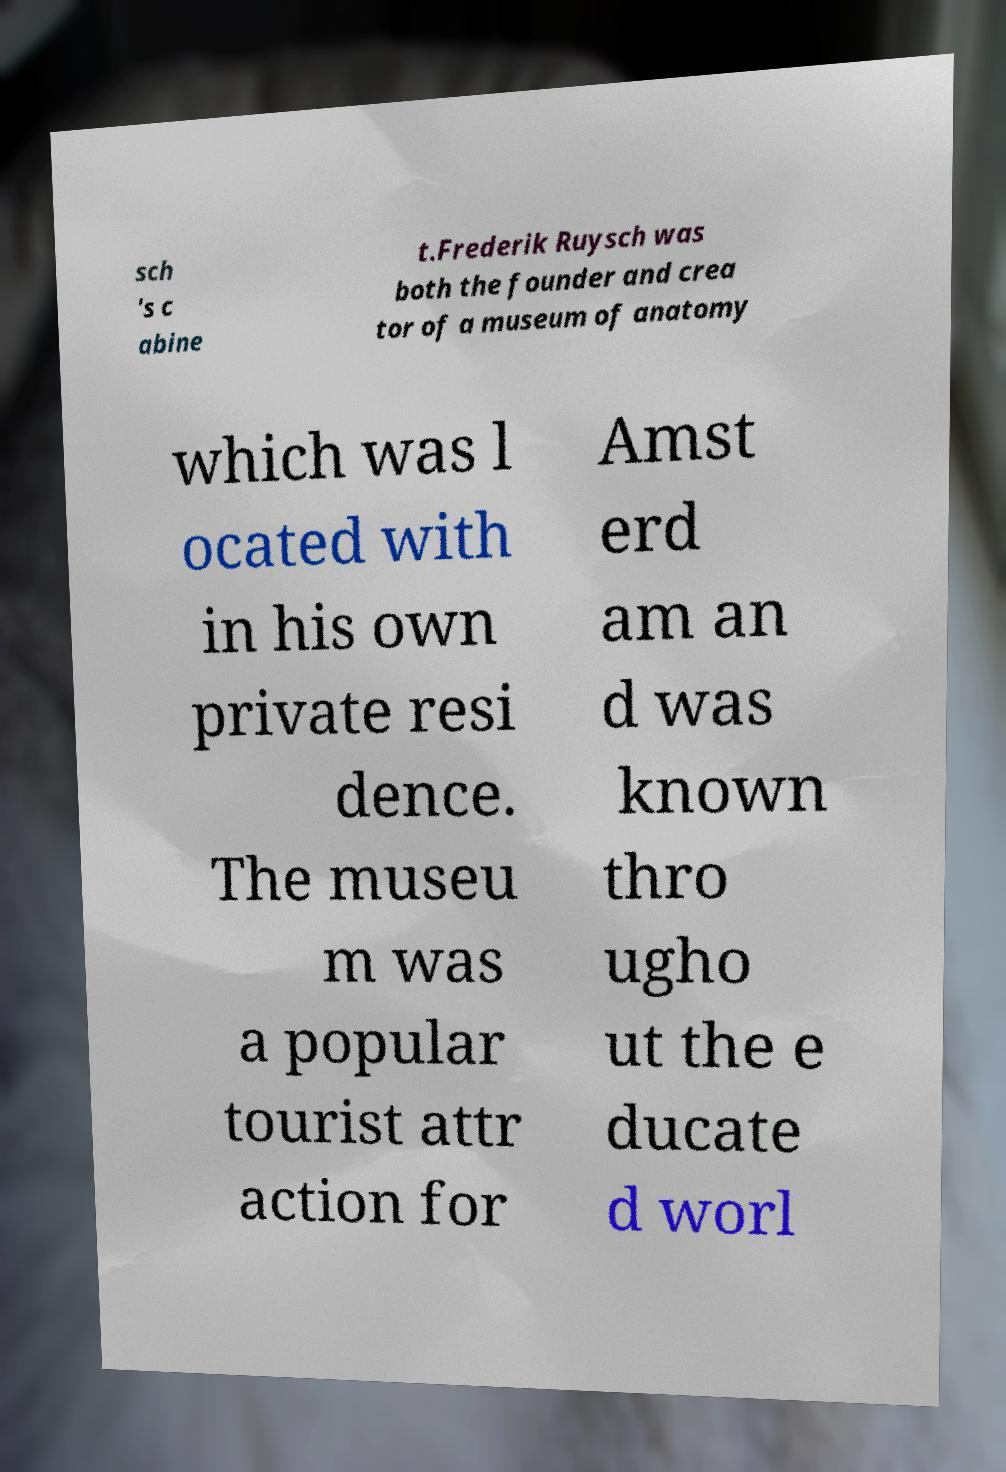For documentation purposes, I need the text within this image transcribed. Could you provide that? sch 's c abine t.Frederik Ruysch was both the founder and crea tor of a museum of anatomy which was l ocated with in his own private resi dence. The museu m was a popular tourist attr action for Amst erd am an d was known thro ugho ut the e ducate d worl 